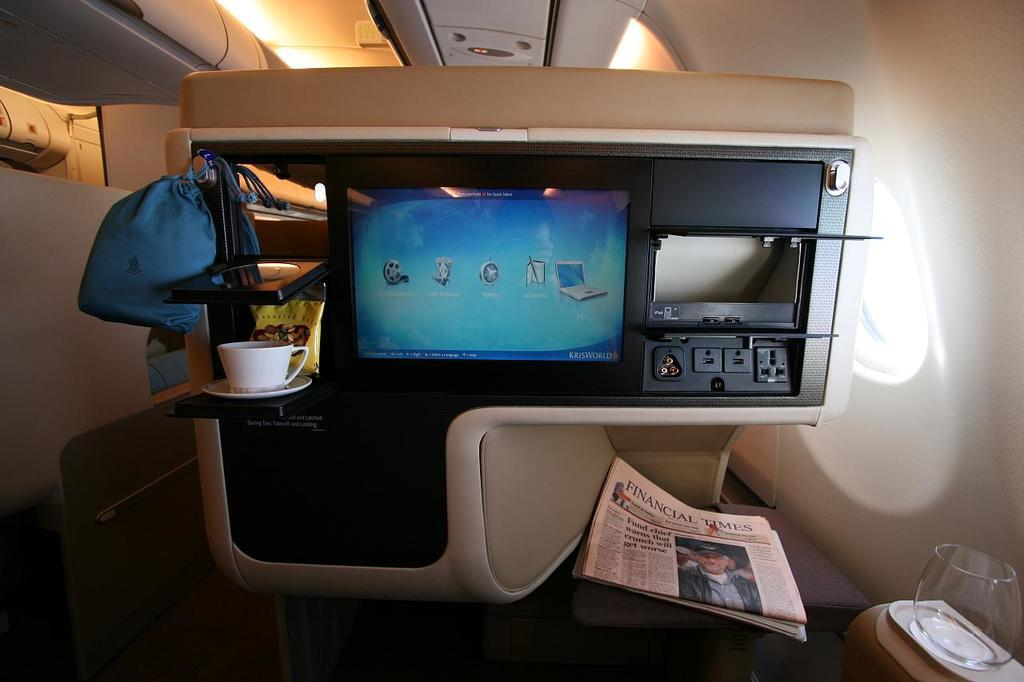<image>
Describe the image concisely. A copy of the Financial Times newspaper lies on the desk. 